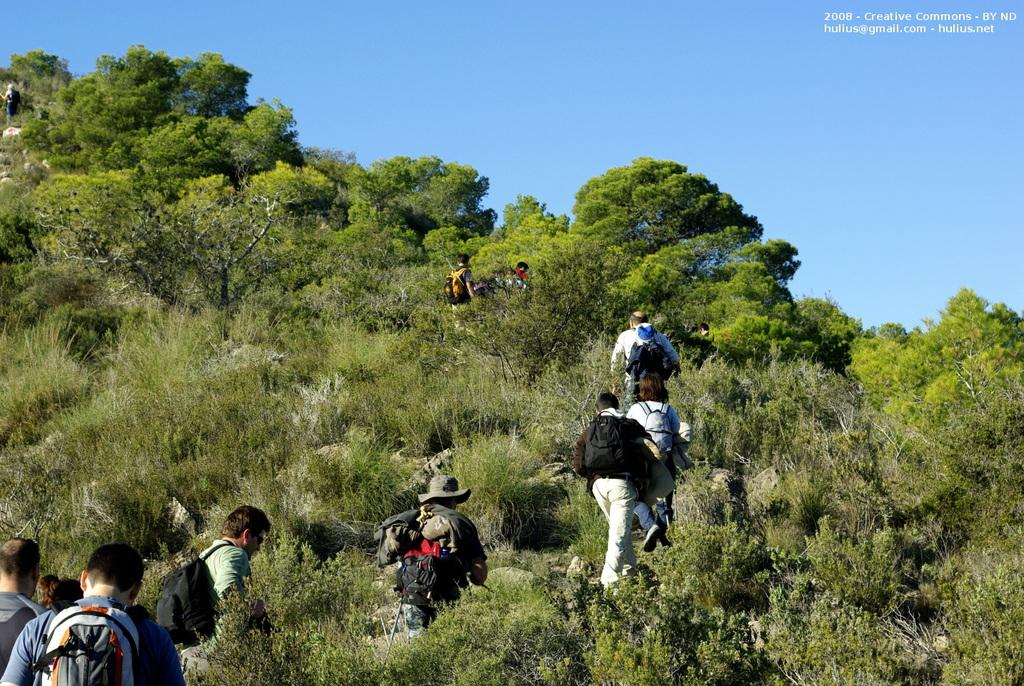What are the people in the image doing? The people in the image are walking on the grass. What can be seen in the background of the image? There are trees in the background of the image. What is visible at the top of the image? The sky is visible at the top of the image. Can you see a cook preparing a meal in the image? There is no cook or meal preparation visible in the image. Is there a toad hopping on the grass in the image? There is no toad present in the image. 